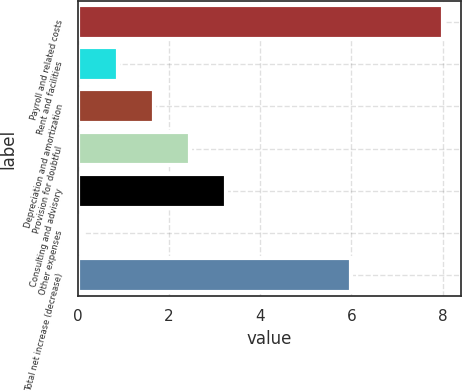<chart> <loc_0><loc_0><loc_500><loc_500><bar_chart><fcel>Payroll and related costs<fcel>Rent and facilities<fcel>Depreciation and amortization<fcel>Provision for doubtful<fcel>Consulting and advisory<fcel>Other expenses<fcel>Total net increase (decrease)<nl><fcel>8<fcel>0.89<fcel>1.68<fcel>2.47<fcel>3.26<fcel>0.1<fcel>6<nl></chart> 